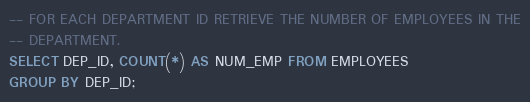<code> <loc_0><loc_0><loc_500><loc_500><_SQL_>-- FOR EACH DEPARTMENT ID RETRIEVE THE NUMBER OF EMPLOYEES IN THE
-- DEPARTMENT.
SELECT DEP_ID, COUNT(*) AS NUM_EMP FROM EMPLOYEES
GROUP BY DEP_ID;</code> 